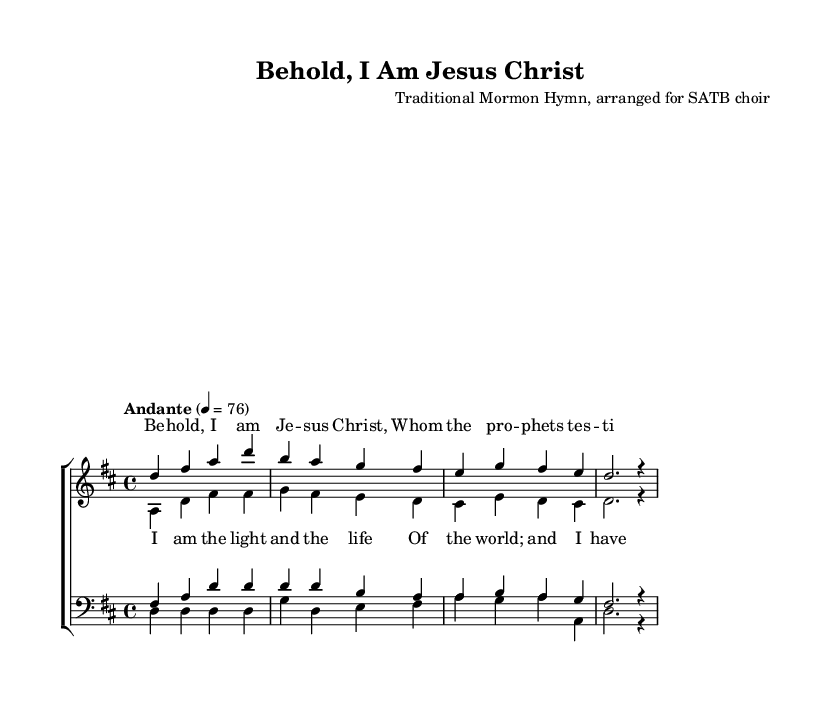What is the key signature of this music? The key signature is D major, indicated by the presence of two sharps (F# and C#) at the beginning of the staff.
Answer: D major What is the time signature of this piece? The time signature is 4/4, shown at the beginning of the sheet music after the clef and key signature. It indicates that there are four beats in each measure.
Answer: 4/4 What is the tempo indication for this piece? The tempo is marked "Andante" with a metronome marking of 76 beats per minute, suggesting a moderately slow pace.
Answer: Andante, 76 How many parts are written for the choir? There are four parts: soprano, alto, tenor, and bass, as indicated by the separate staves labeled for each voice type within the choir staff.
Answer: Four What is the title of this piece? The title "Behold, I Am Jesus Christ" is displayed at the top of the sheet music under the header section, indicating the name of the arrangement.
Answer: Behold, I Am Jesus Christ What are the first two words of the first verse? The first two words of the first verse are "Behold, I," taken directly from the lyrics written beneath the soprano staff indicating the text for that voice part.
Answer: Behold, I What type of arrangement is this piece specifically for? This piece is arranged for SATB choir, meaning it is designed for Soprano, Alto, Tenor, and Bass voices, as denoted in the score's header.
Answer: SATB 